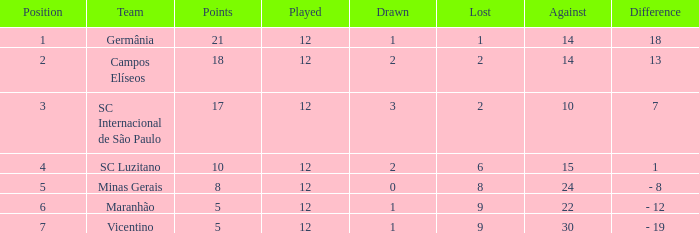What distinction has a score exceeding 10, and a tie below 2? 18.0. 